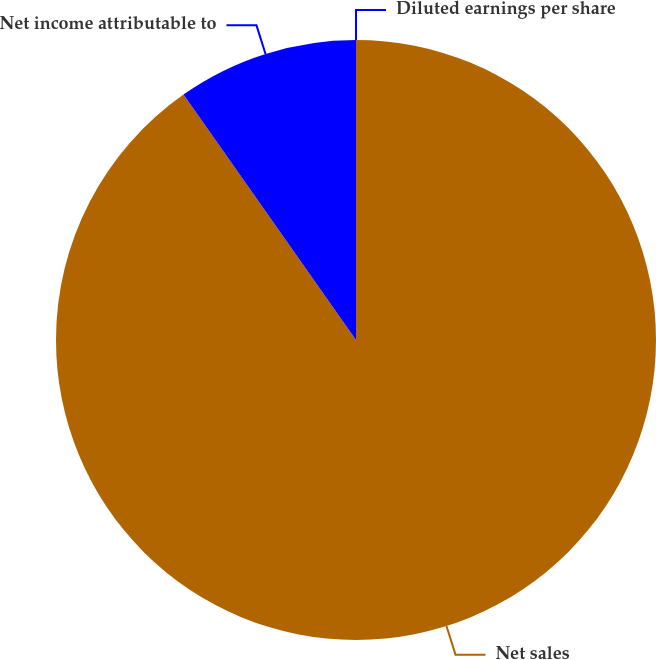Convert chart. <chart><loc_0><loc_0><loc_500><loc_500><pie_chart><fcel>Net sales<fcel>Net income attributable to<fcel>Diluted earnings per share<nl><fcel>90.25%<fcel>9.75%<fcel>0.0%<nl></chart> 